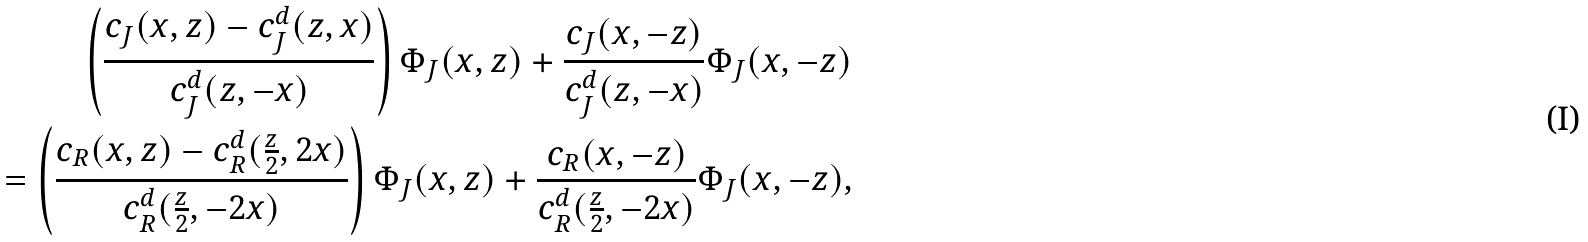Convert formula to latex. <formula><loc_0><loc_0><loc_500><loc_500>\left ( \frac { c _ { J } ( x , z ) - c _ { J } ^ { d } ( z , x ) } { c _ { J } ^ { d } ( z , - x ) } \right ) \Phi _ { J } ( x , z ) + \frac { c _ { J } ( x , - z ) } { c _ { J } ^ { d } ( z , - x ) } \Phi _ { J } ( x , - z ) \\ \quad = \left ( \frac { c _ { R } ( x , z ) - c _ { R } ^ { d } ( \frac { z } { 2 } , 2 x ) } { c _ { R } ^ { d } ( \frac { z } { 2 } , - 2 x ) } \right ) \Phi _ { J } ( x , z ) + \frac { c _ { R } ( x , - z ) } { c _ { R } ^ { d } ( \frac { z } { 2 } , - 2 x ) } \Phi _ { J } ( x , - z ) ,</formula> 